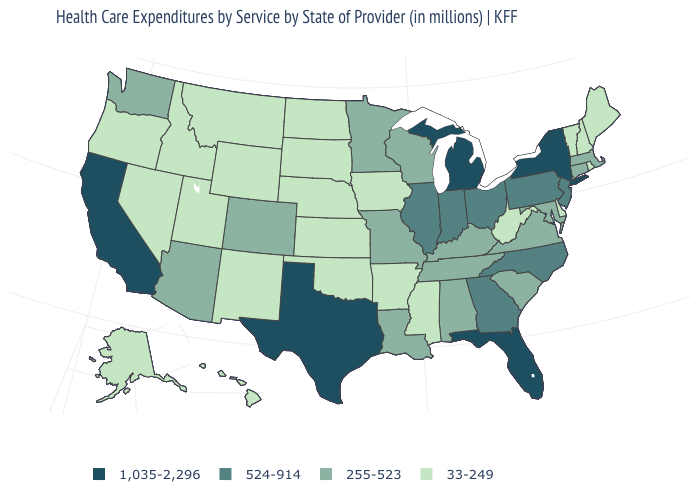Name the states that have a value in the range 255-523?
Keep it brief. Alabama, Arizona, Colorado, Connecticut, Kentucky, Louisiana, Maryland, Massachusetts, Minnesota, Missouri, South Carolina, Tennessee, Virginia, Washington, Wisconsin. What is the value of Idaho?
Concise answer only. 33-249. What is the value of Kansas?
Give a very brief answer. 33-249. Name the states that have a value in the range 255-523?
Be succinct. Alabama, Arizona, Colorado, Connecticut, Kentucky, Louisiana, Maryland, Massachusetts, Minnesota, Missouri, South Carolina, Tennessee, Virginia, Washington, Wisconsin. Does Florida have the lowest value in the South?
Answer briefly. No. Among the states that border Rhode Island , which have the highest value?
Quick response, please. Connecticut, Massachusetts. What is the value of Minnesota?
Quick response, please. 255-523. Does Massachusetts have the lowest value in the Northeast?
Short answer required. No. What is the value of South Dakota?
Give a very brief answer. 33-249. What is the value of Indiana?
Be succinct. 524-914. What is the value of Alaska?
Be succinct. 33-249. What is the lowest value in states that border Illinois?
Write a very short answer. 33-249. Is the legend a continuous bar?
Give a very brief answer. No. What is the value of North Dakota?
Be succinct. 33-249. Among the states that border West Virginia , does Virginia have the highest value?
Keep it brief. No. 